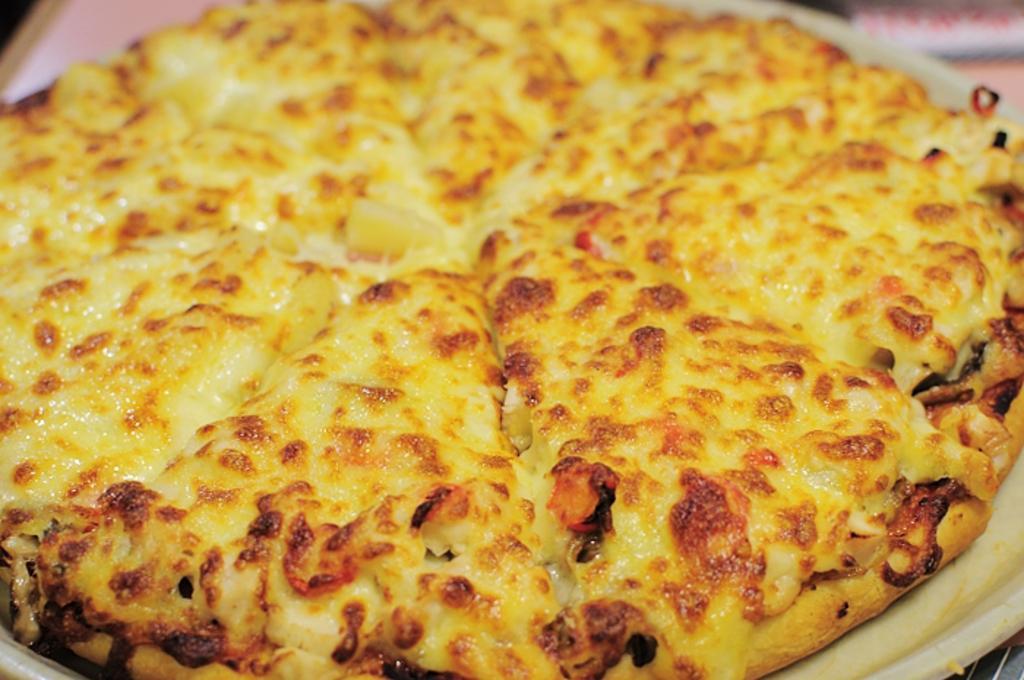Describe this image in one or two sentences. In this picture we can see a pizza in the front, there is a blurry background. 